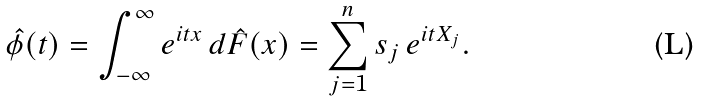<formula> <loc_0><loc_0><loc_500><loc_500>\hat { \phi } ( t ) & = \int _ { - \infty } ^ { \infty } e ^ { i t x } \, d \hat { F } ( x ) = \sum _ { j = 1 } ^ { n } s _ { j } \, e ^ { i t X _ { j } } .</formula> 